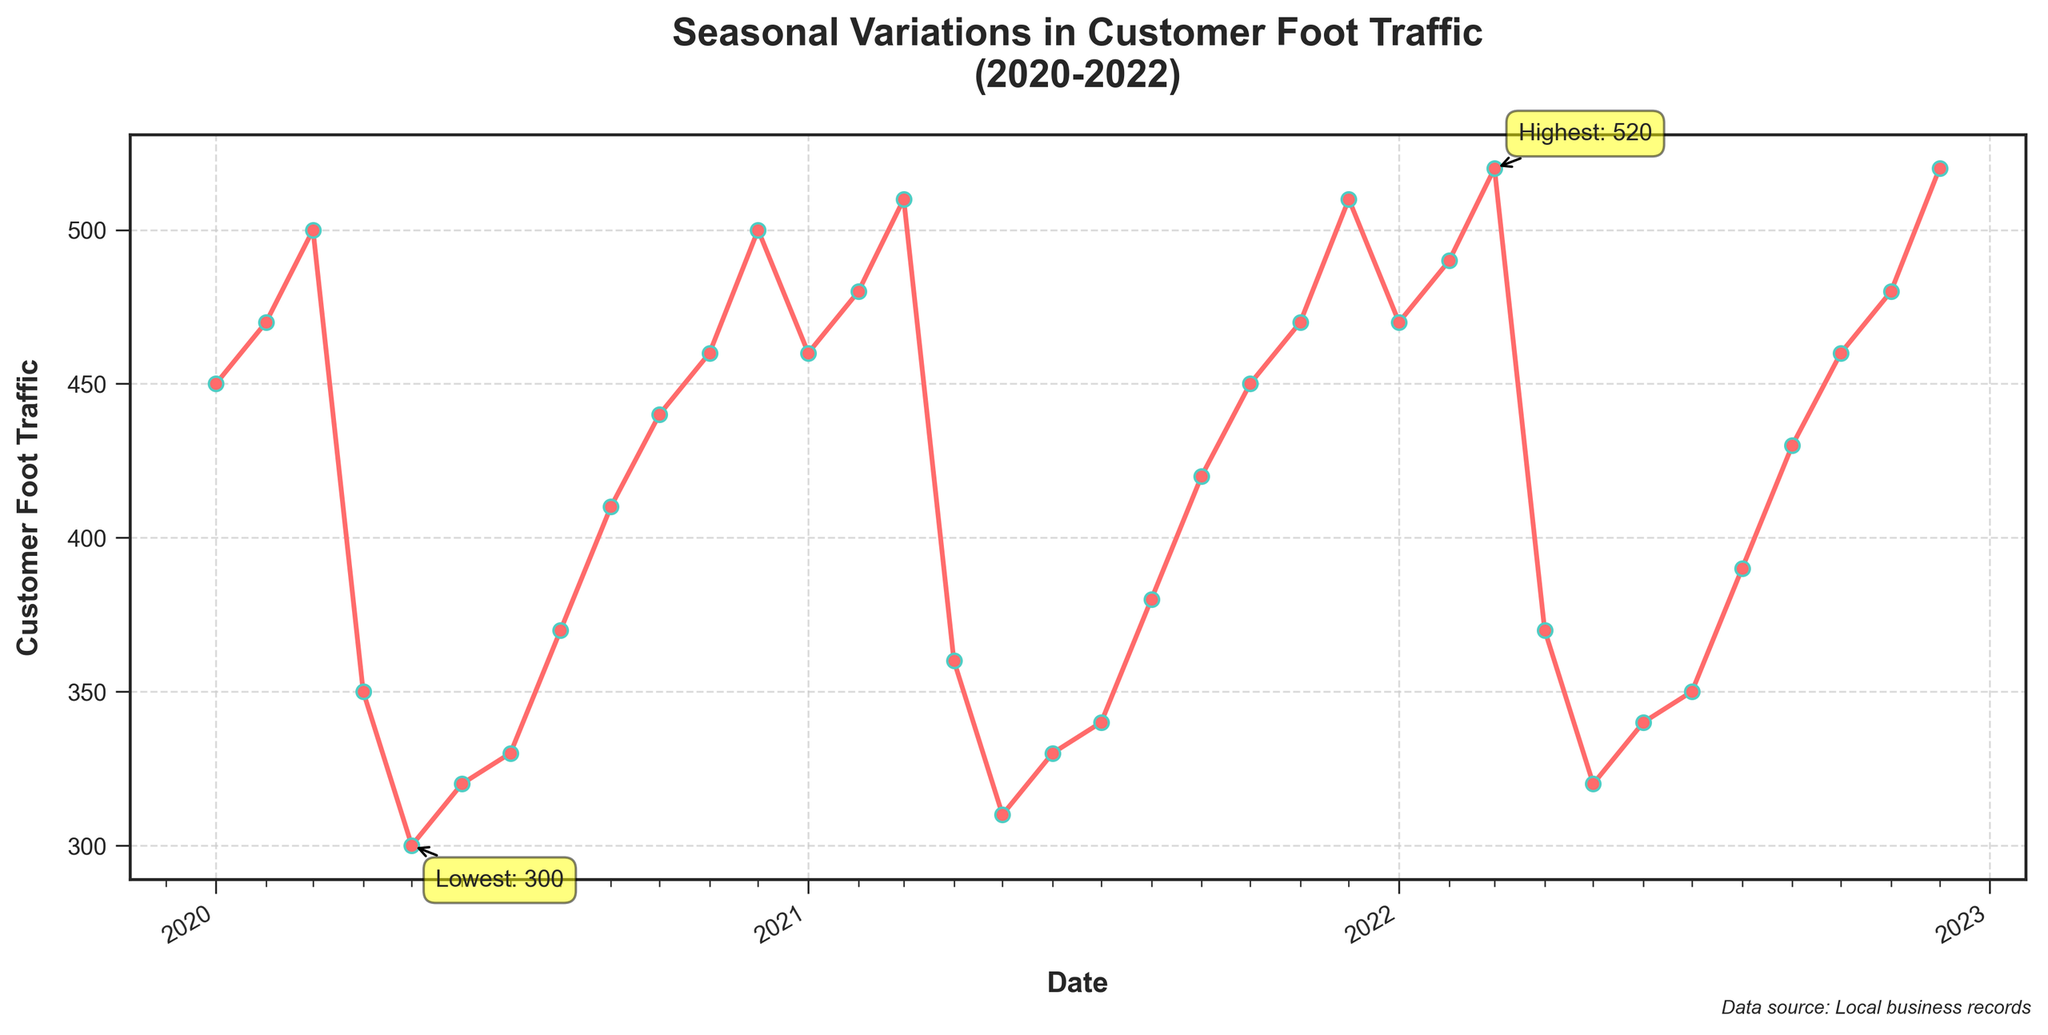What is the title of the plot? The title is usually found at the top of the plot and summarizes the main subject of the figure. In this case, it reads "Seasonal Variations in Customer Foot Traffic (2020-2022)."
Answer: Seasonal Variations in Customer Foot Traffic (2020-2022) What is the y-axis label? The y-axis label usually indicates what is being measured in numerical terms. In this plot, the y-axis label is "Customer Foot Traffic."
Answer: Customer Foot Traffic When was the highest customer foot traffic observed? The plot includes annotations highlighting the points of highest and lowest customer foot traffic. The highest traffic annotation points to December 2022.
Answer: December 2022 What is the average foot traffic in the month of December across all three years? Average is calculated by summing up the December values for each year (500 for 2020, 510 for 2021, and 520 for 2022) and then dividing by 3. (500 + 510 + 520) / 3 = 510
Answer: 510 Which month consistently shows a decrease in customer foot traffic each year? By scanning the plot, April shows a consistent drop each year with values of 350 in 2020, 360 in 2021, and 370 in 2022.
Answer: April Compare the customer foot traffic between January 2020 and January 2022. By looking at the points for January in 2020 and 2022, the traffic values are 450 and 470 respectively. January 2022 has higher traffic.
Answer: January 2022 has higher traffic What is the trend of customer foot traffic from March to June each year? Observing the sequence of points from March to June for each year, there is a noticeable downward trend each year: traffic decreases from March through June.
Answer: Downward trend What is the lowest customer foot traffic observed and when did it occur? The plot includes an annotation for the lowest traffic, marking May 2020 with a value of 300 as the point.
Answer: May 2020 How does the customer foot traffic change between August and November each year? Observing the data points from August to November each year, there's an increase in foot traffic each year from August to November.
Answer: Increase What is the difference in customer foot traffic between the highest and lowest months? The highest value is 520 (December 2022), and the lowest is 300 (May 2020). The difference is 520 - 300 = 220.
Answer: 220 